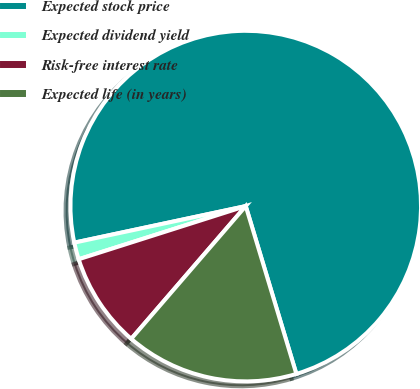Convert chart to OTSL. <chart><loc_0><loc_0><loc_500><loc_500><pie_chart><fcel>Expected stock price<fcel>Expected dividend yield<fcel>Risk-free interest rate<fcel>Expected life (in years)<nl><fcel>73.68%<fcel>1.56%<fcel>8.77%<fcel>15.99%<nl></chart> 